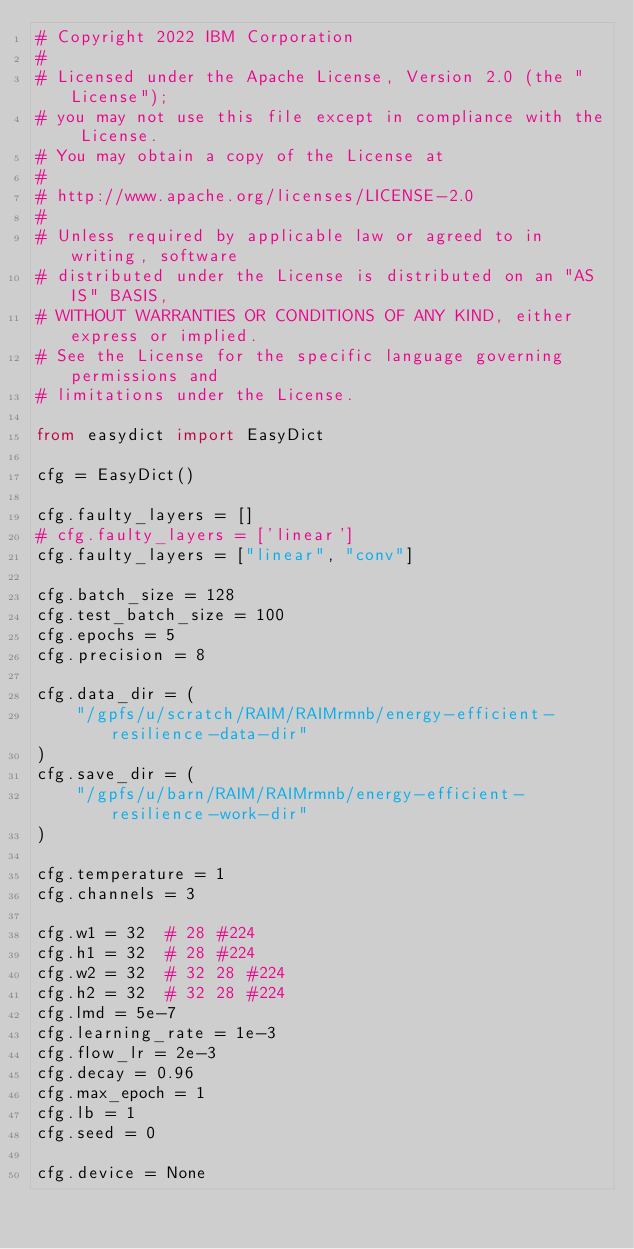Convert code to text. <code><loc_0><loc_0><loc_500><loc_500><_Python_># Copyright 2022 IBM Corporation
#
# Licensed under the Apache License, Version 2.0 (the "License");
# you may not use this file except in compliance with the License.
# You may obtain a copy of the License at
#
# http://www.apache.org/licenses/LICENSE-2.0
#
# Unless required by applicable law or agreed to in writing, software
# distributed under the License is distributed on an "AS IS" BASIS,
# WITHOUT WARRANTIES OR CONDITIONS OF ANY KIND, either express or implied.
# See the License for the specific language governing permissions and
# limitations under the License.

from easydict import EasyDict

cfg = EasyDict()

cfg.faulty_layers = []
# cfg.faulty_layers = ['linear']
cfg.faulty_layers = ["linear", "conv"]

cfg.batch_size = 128
cfg.test_batch_size = 100
cfg.epochs = 5
cfg.precision = 8

cfg.data_dir = (
    "/gpfs/u/scratch/RAIM/RAIMrmnb/energy-efficient-resilience-data-dir"
)
cfg.save_dir = (
    "/gpfs/u/barn/RAIM/RAIMrmnb/energy-efficient-resilience-work-dir"
)

cfg.temperature = 1
cfg.channels = 3

cfg.w1 = 32  # 28 #224
cfg.h1 = 32  # 28 #224
cfg.w2 = 32  # 32 28 #224
cfg.h2 = 32  # 32 28 #224
cfg.lmd = 5e-7
cfg.learning_rate = 1e-3
cfg.flow_lr = 2e-3
cfg.decay = 0.96
cfg.max_epoch = 1
cfg.lb = 1
cfg.seed = 0

cfg.device = None
</code> 